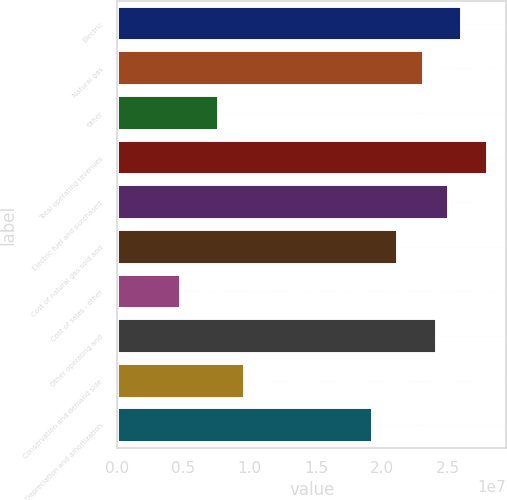<chart> <loc_0><loc_0><loc_500><loc_500><bar_chart><fcel>Electric<fcel>Natural gas<fcel>Other<fcel>Total operating revenues<fcel>Electric fuel and purchased<fcel>Cost of natural gas sold and<fcel>Cost of sales - other<fcel>Other operating and<fcel>Conservation and demand side<fcel>Depreciation and amortization<nl><fcel>2.60396e+07<fcel>2.31463e+07<fcel>7.71544e+06<fcel>2.79685e+07<fcel>2.50752e+07<fcel>2.12175e+07<fcel>4.82215e+06<fcel>2.41108e+07<fcel>9.6443e+06<fcel>1.92886e+07<nl></chart> 